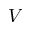Convert formula to latex. <formula><loc_0><loc_0><loc_500><loc_500>V</formula> 